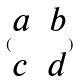Convert formula to latex. <formula><loc_0><loc_0><loc_500><loc_500>( \begin{matrix} a & b \\ c & d \end{matrix} )</formula> 